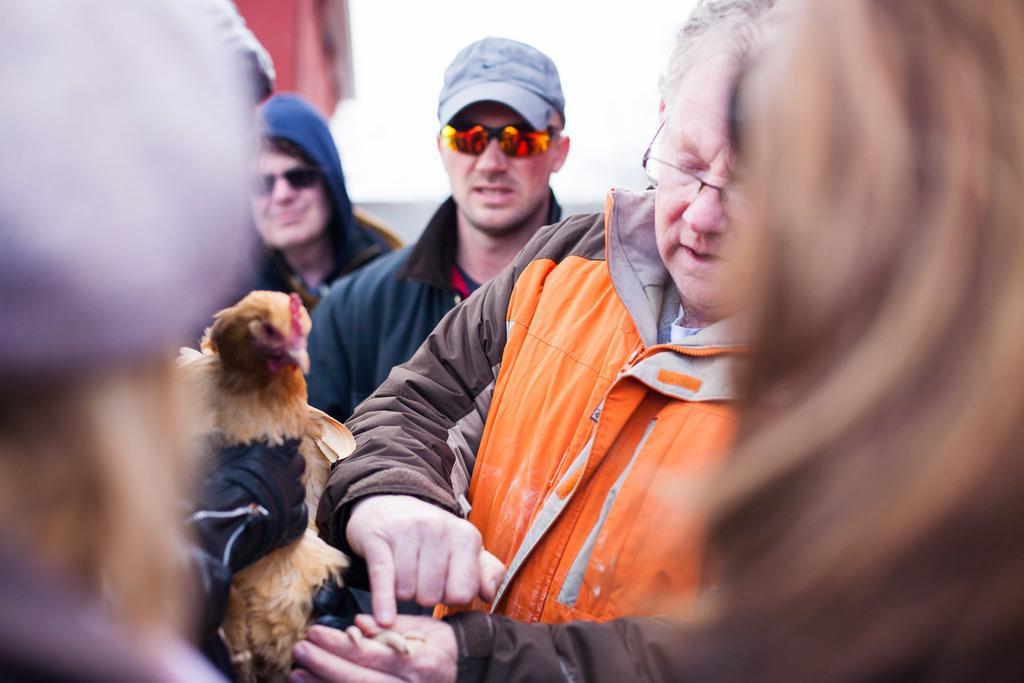Please provide a concise description of this image. In this picture there is a man wearing an orange jacket. Beside him, there is a man wearing a blue jacket, grey cap and goggles. Towards the left and right, there are people. 